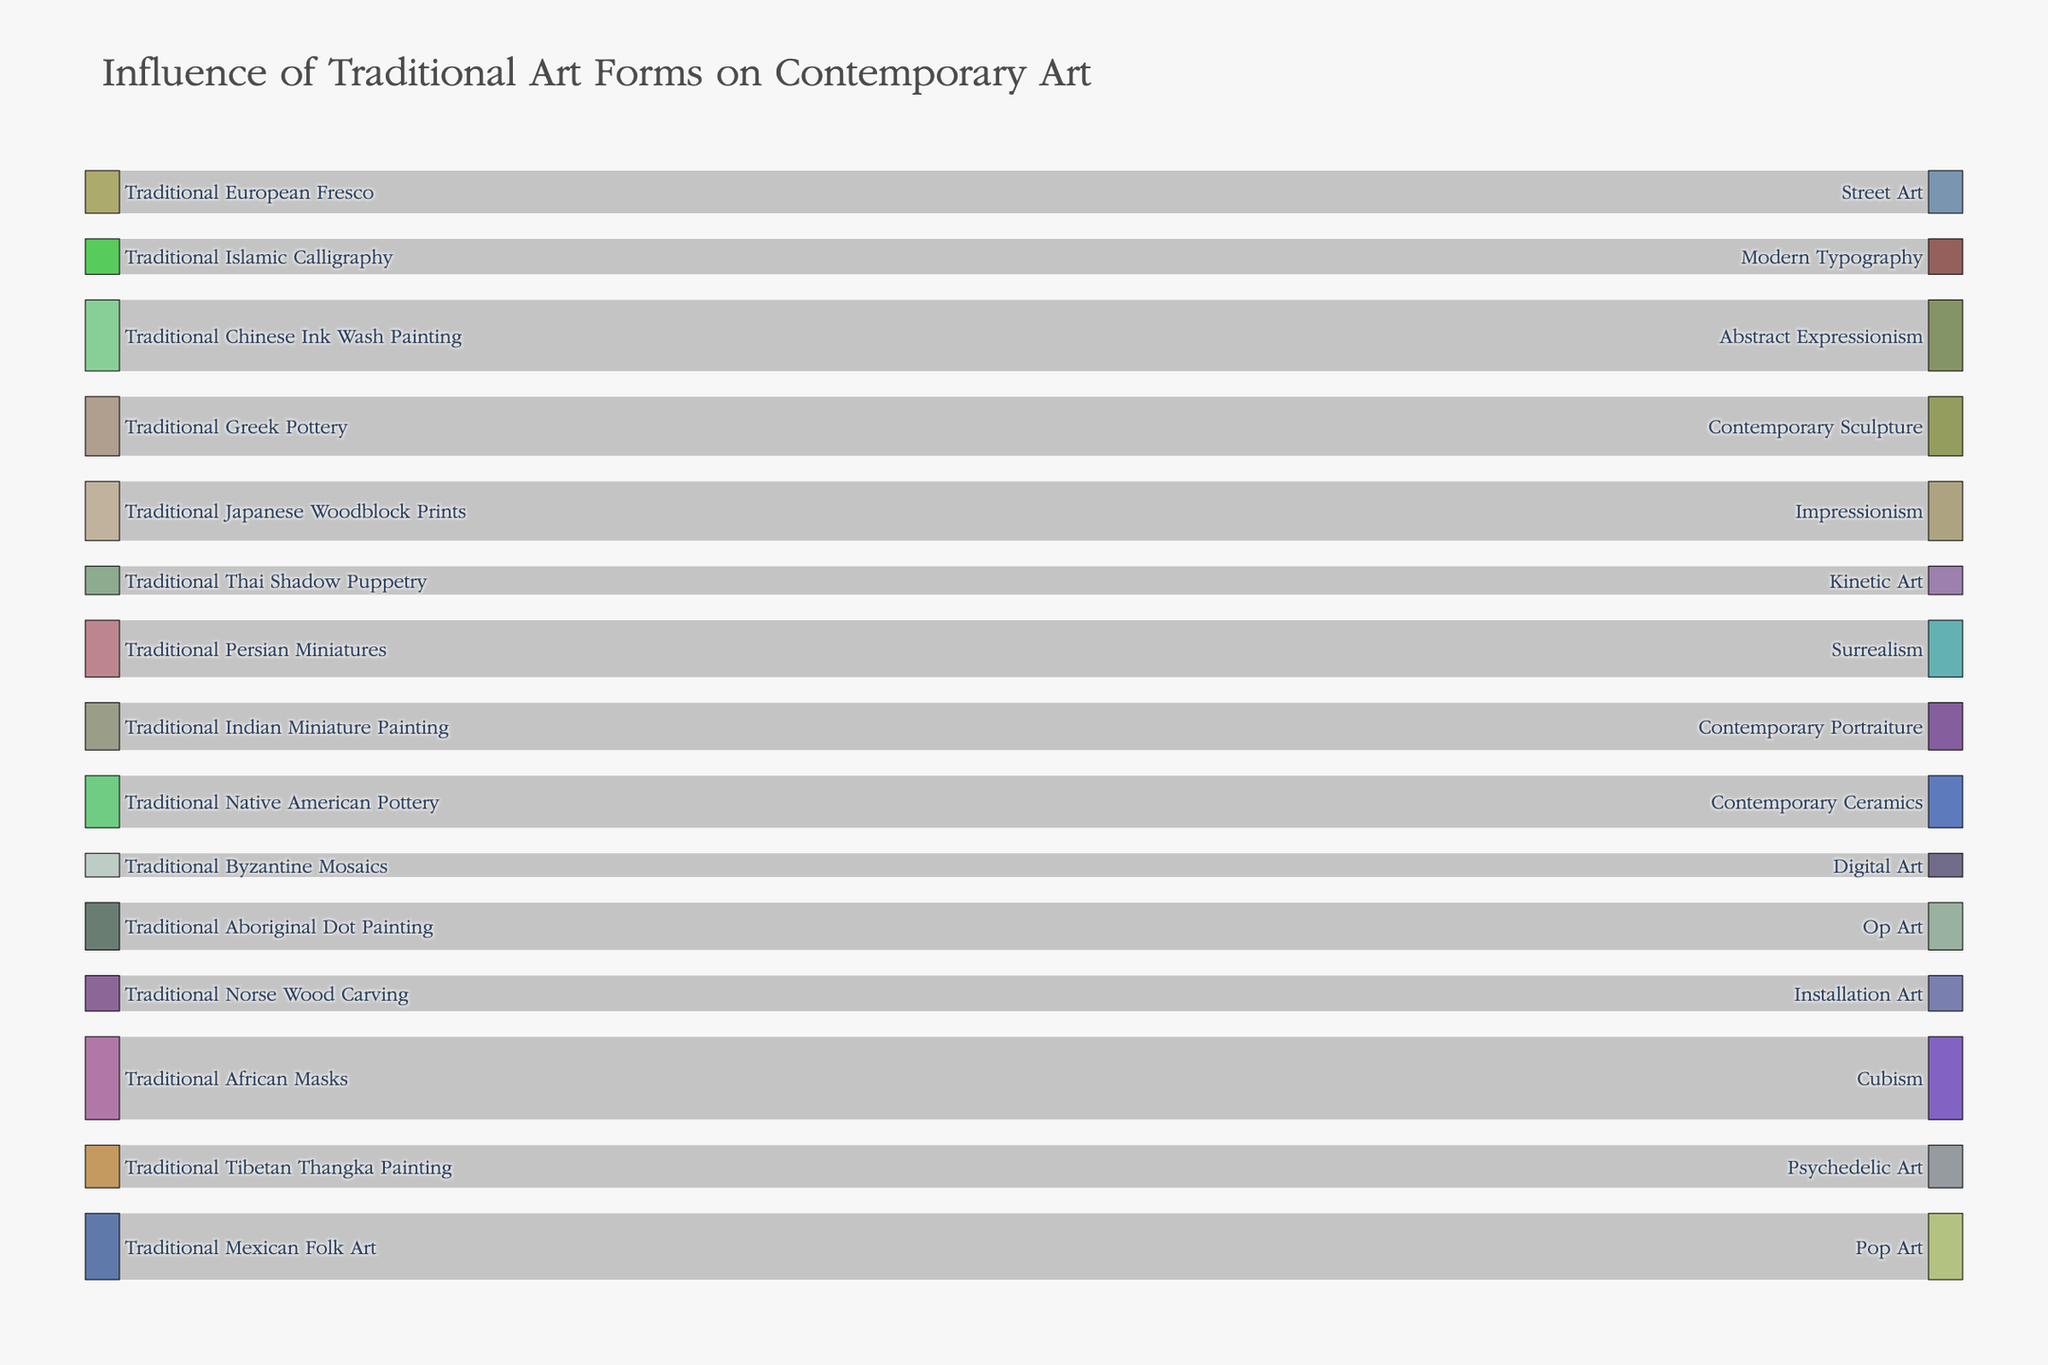What is the title of the figure? The title of the figure is found at the top and usually describes the overall content.
Answer: Influence of Traditional Art Forms on Contemporary Art Which traditional art form has the highest influence on a contemporary art style? To find the highest influence, look for the link with the highest value. The "Traditional African Masks" link to "Cubism" has the highest value.
Answer: Traditional African Masks How many traditional art forms influence contemporary styles in total? Count all unique traditional art forms listed as sources. There are 15 unique traditional art forms listed.
Answer: 15 Which contemporary art style is influenced by "Traditional Japanese Woodblock Prints"? Locate the link originating from "Traditional Japanese Woodblock Prints" and check its target. The target is "Impressionism".
Answer: Impressionism What is the combined influence value of "Traditional Chinese Ink Wash Painting" and "Traditional Indian Miniature Painting"? Sum the influence values for these two art forms: 30 (Ink Wash Painting) + 20 (Indian Miniature Painting) = 50.
Answer: 50 What is the difference in influence values between "Traditional Native American Pottery" and "Traditional Persian Miniatures"? Subtract the smaller influence value from the larger one: 24 (Persian Miniatures) - 22 (Native American Pottery) = 2.
Answer: 2 Which contemporary art style has the most direct influences from traditional art forms? Count the number of links targeting each contemporary style. "Cubism" and "Pop Art" both have only one direct influence each, but Cubism has the highest influence value.
Answer: Cubism Identify a link with the least influence value. Which traditional art form and contemporary art style are connected by this link? Locate the link with the smallest value of 10, which connects "Traditional Byzantine Mosaics" to "Digital Art".
Answer: Traditional Byzantine Mosaics to Digital Art Which traditional art form has an influence on "Street Art"? Locate the link where the target is "Street Art" and find its source. The source is "Traditional European Fresco".
Answer: Traditional European Fresco Are there more traditional art forms influencing modern typography or contemporary sculpture? Count the links targeting each of these contemporary styles: Modern Typography has 1 influence (Islamic Calligraphy), and Contemporary Sculpture has 1 influence (Greek Pottery), so they are equal.
Answer: Equal 